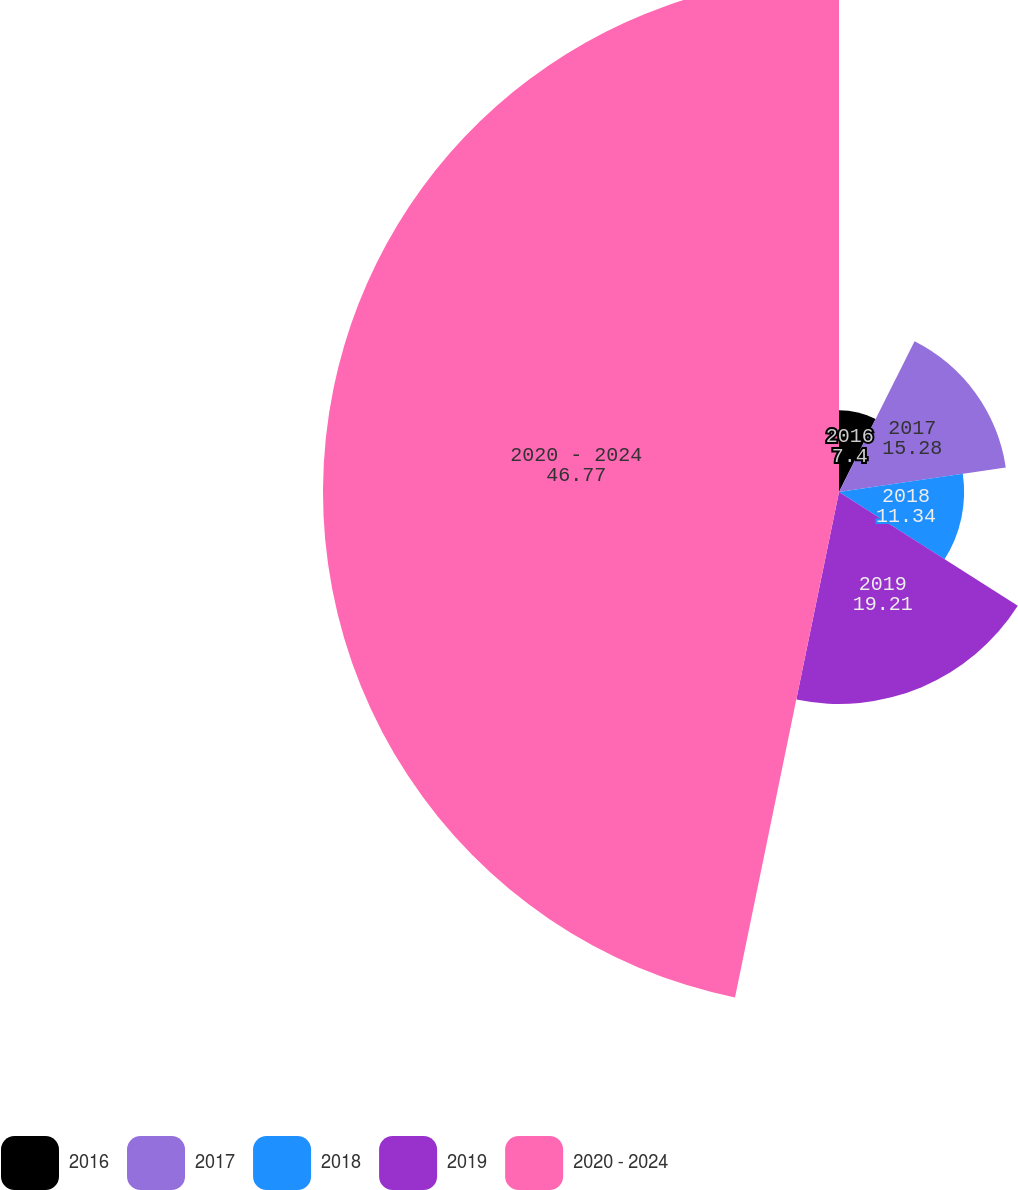<chart> <loc_0><loc_0><loc_500><loc_500><pie_chart><fcel>2016<fcel>2017<fcel>2018<fcel>2019<fcel>2020 - 2024<nl><fcel>7.4%<fcel>15.28%<fcel>11.34%<fcel>19.21%<fcel>46.77%<nl></chart> 